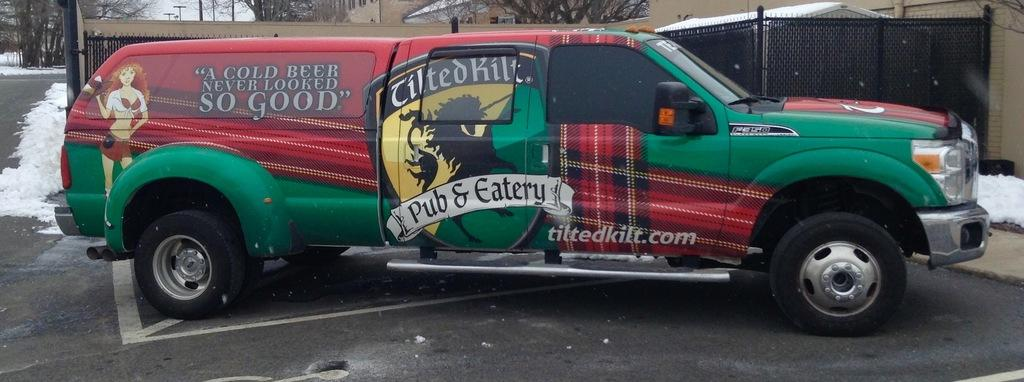What is the main subject in the foreground of the image? There is a vehicle on the road in the foreground. What can be seen on the left side of the road? There is snow on the left side of the road. What is visible in the background of the image? There is a building, a metal fence, and trees in the background. Can you see any deer running alongside the vehicle in the image? There are no deer present in the image; it only features a vehicle on the road, snow on the left side, and background elements. 